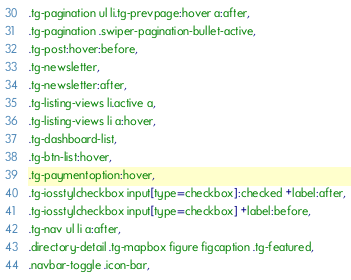Convert code to text. <code><loc_0><loc_0><loc_500><loc_500><_CSS_>.tg-pagination ul li.tg-prevpage:hover a:after,
.tg-pagination .swiper-pagination-bullet-active,
.tg-post:hover:before,
.tg-newsletter,
.tg-newsletter:after,
.tg-listing-views li.active a,
.tg-listing-views li a:hover,
.tg-dashboard-list,
.tg-btn-list:hover,
.tg-paymentoption:hover,
.tg-iosstylcheckbox input[type=checkbox]:checked +label:after,
.tg-iosstylcheckbox input[type=checkbox] +label:before,
.tg-nav ul li a:after,
.directory-detail .tg-mapbox figure figcaption .tg-featured,
.navbar-toggle .icon-bar,</code> 